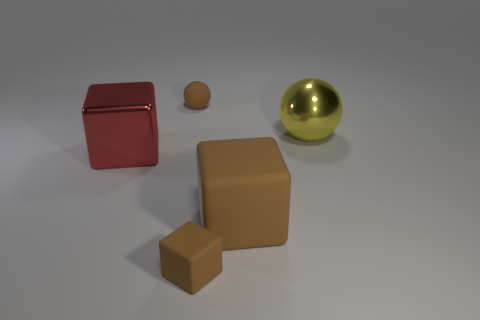There is a tiny ball that is the same material as the tiny brown cube; what color is it?
Your response must be concise. Brown. Are there the same number of red cubes in front of the big brown cube and large brown matte balls?
Offer a very short reply. Yes. The brown thing that is the same size as the yellow shiny thing is what shape?
Offer a terse response. Cube. How many other objects are there of the same shape as the red metal thing?
Provide a short and direct response. 2. There is a yellow ball; is it the same size as the rubber thing behind the big brown rubber cube?
Keep it short and to the point. No. What number of things are metal objects that are to the right of the tiny brown matte ball or brown objects?
Give a very brief answer. 4. What is the shape of the small brown thing that is behind the small block?
Your answer should be compact. Sphere. Are there an equal number of big yellow metal objects to the right of the tiny brown sphere and red things that are to the right of the large metal block?
Your answer should be very brief. No. There is a block that is both left of the big matte object and to the right of the large shiny cube; what is its color?
Your response must be concise. Brown. There is a tiny brown thing behind the cube in front of the large matte thing; what is its material?
Your answer should be very brief. Rubber. 